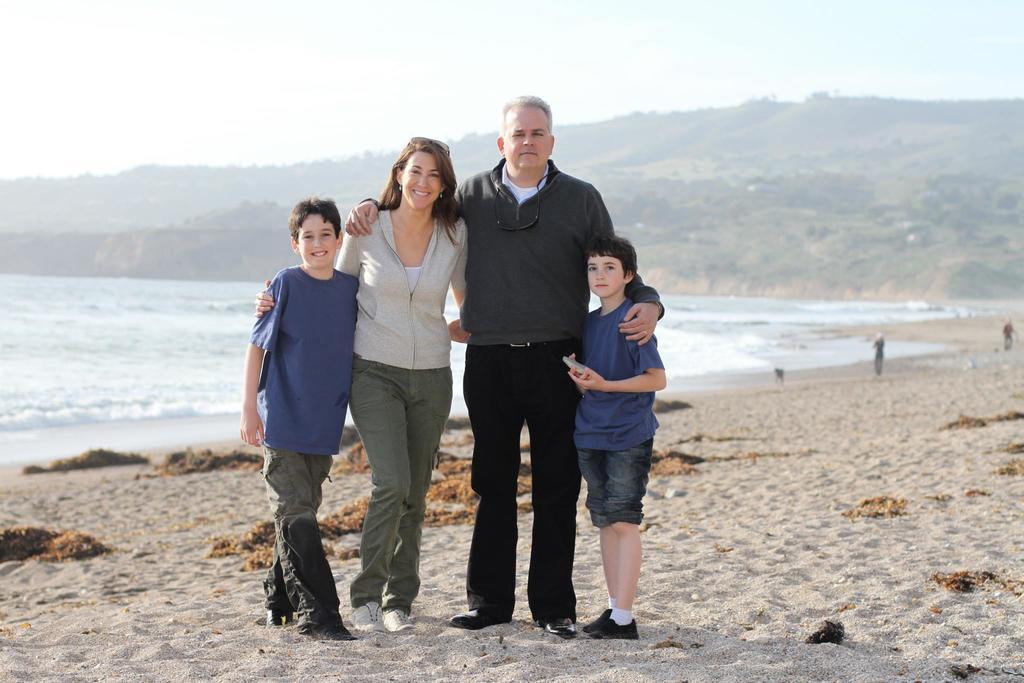How many people are present in the image? There are a guy, a lady, and two kids in the image, making a total of four people. What is the setting of the image? The location of the image is a beach. What type of plough can be seen being used by the group in the image? There is no plough present in the image; it is a beach setting with people. How many people are pushing the plough in the image? There is no plough or pushing activity present in the image. 